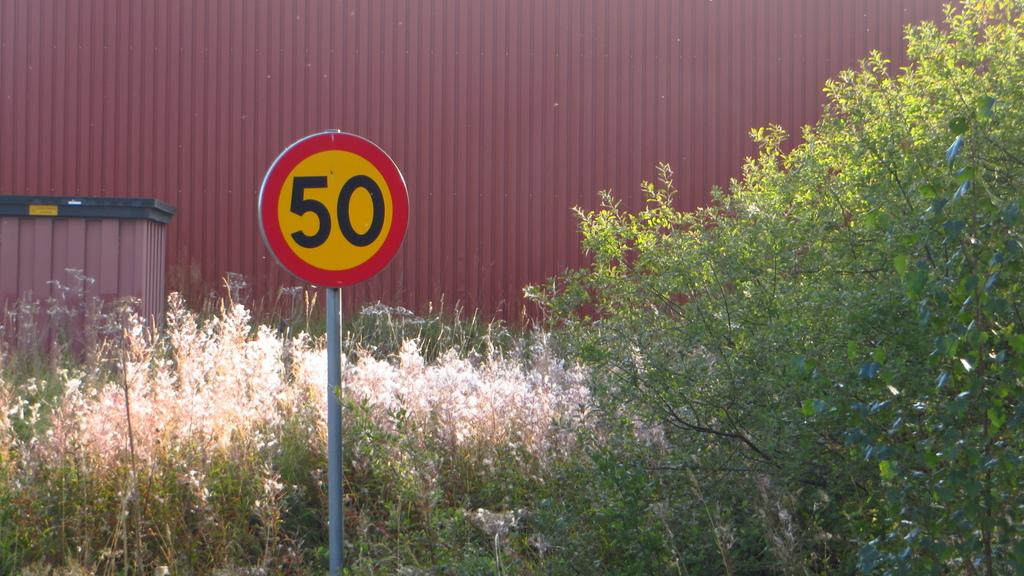<image>
Write a terse but informative summary of the picture. A sign with the number 50 on it can be seen in front of a building. 